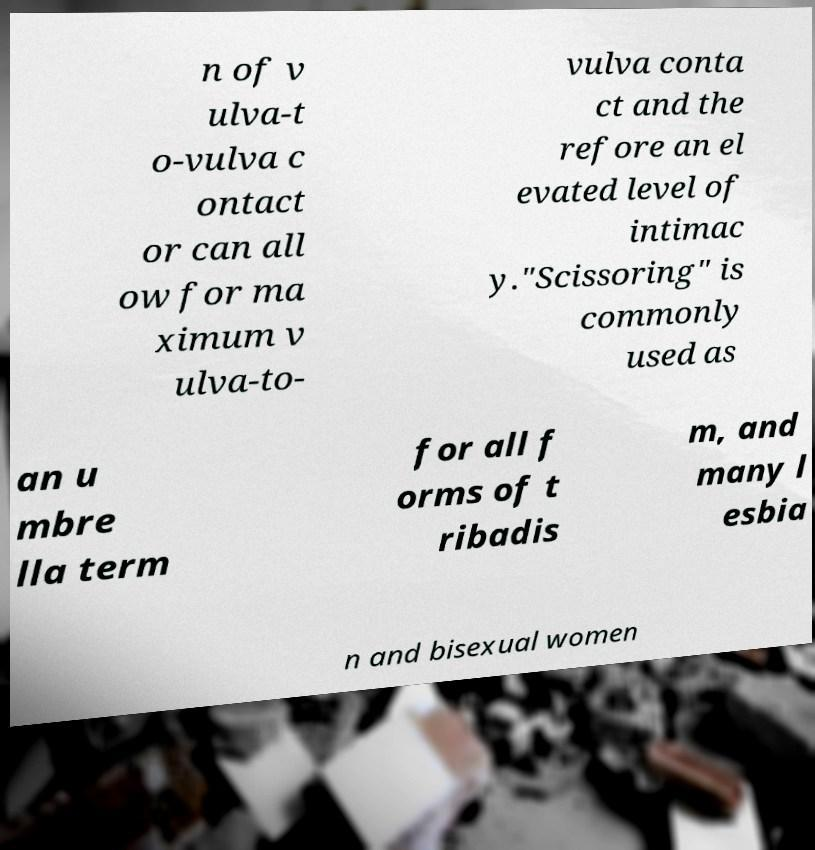Can you read and provide the text displayed in the image?This photo seems to have some interesting text. Can you extract and type it out for me? n of v ulva-t o-vulva c ontact or can all ow for ma ximum v ulva-to- vulva conta ct and the refore an el evated level of intimac y."Scissoring" is commonly used as an u mbre lla term for all f orms of t ribadis m, and many l esbia n and bisexual women 